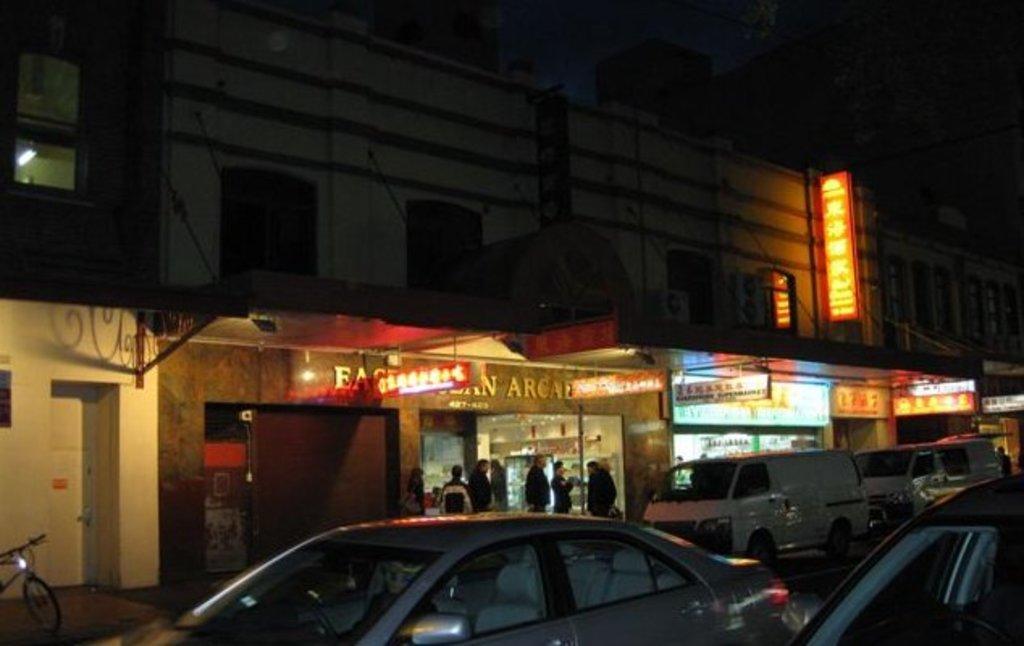Could you give a brief overview of what you see in this image? In this image there are buildings and stalls, there are a few boards with some text is hanging from the ceiling of the stalls, in front of the stalls there are a few people standing and there are a few vehicles parked. The background is dark. 